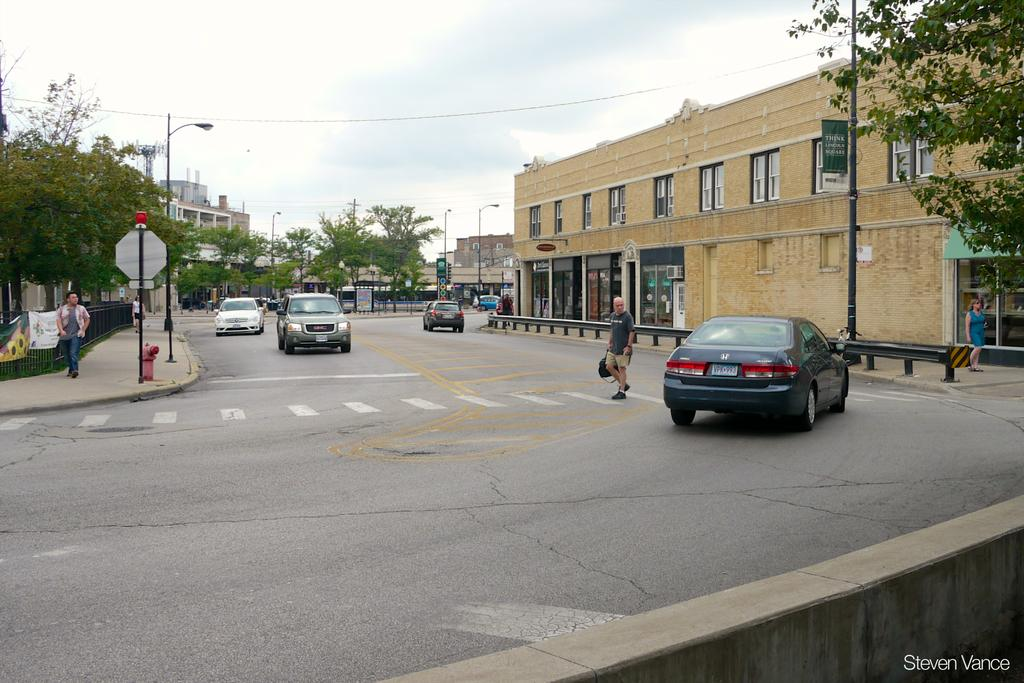What can be seen moving on the road in the image? There are cars on the road in the image. What type of informational or directional objects are present in the image? There are sign boards in the image. What structures can be seen supporting the wires? There are poles in the image. What type of infrastructure is visible in the image? There are wires in the image. What type of natural elements are present in the image? There are trees in the image. What type of living beings are present in the image? There are people in the image. What type of man-made structures are present in the image? There are buildings in the image. What type of pie is being served at the outdoor event in the image? There is no pie or outdoor event present in the image. What type of hair accessory is the person wearing in the image? There is no person wearing a hair accessory in the image. 